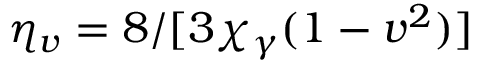Convert formula to latex. <formula><loc_0><loc_0><loc_500><loc_500>\eta _ { v } = 8 / [ 3 \chi _ { \gamma } ( 1 - v ^ { 2 } ) ]</formula> 